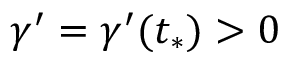Convert formula to latex. <formula><loc_0><loc_0><loc_500><loc_500>\gamma ^ { \prime } = \gamma ^ { \prime } ( t _ { * } ) > 0</formula> 